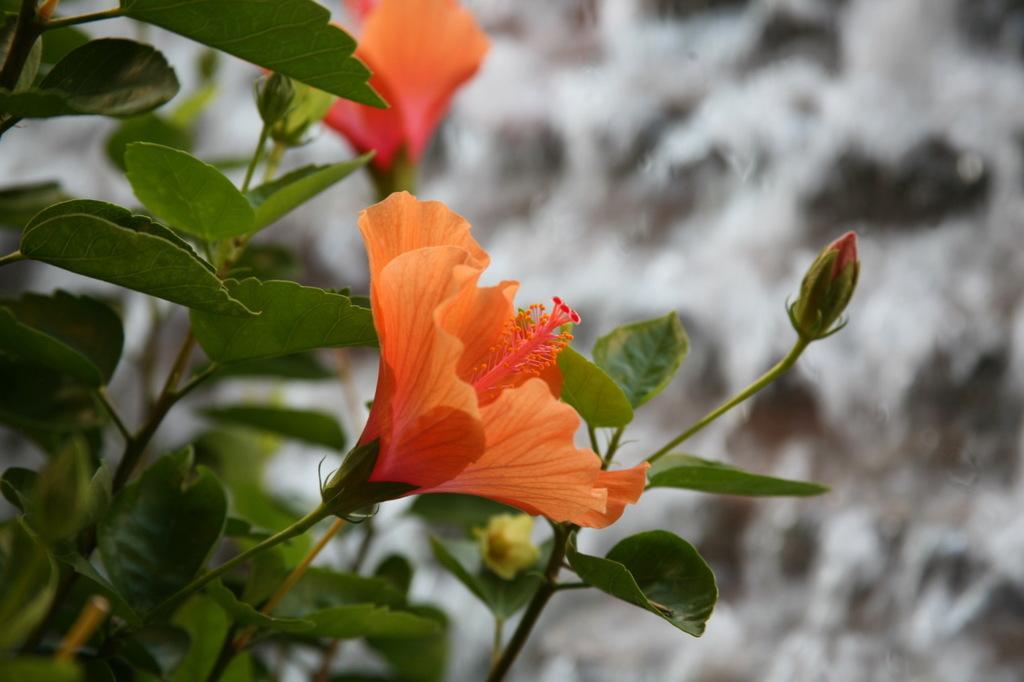Could you give a brief overview of what you see in this image? In this image we can see orange color hibiscus flowers of a plant. The background of the image is blurred. 